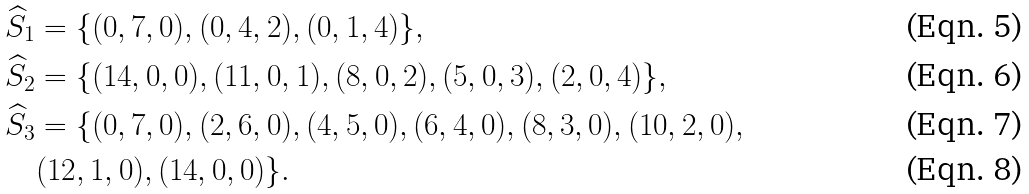<formula> <loc_0><loc_0><loc_500><loc_500>& \widehat { S } _ { 1 } = \{ ( 0 , 7 , 0 ) , ( 0 , 4 , 2 ) , ( 0 , 1 , 4 ) \} , \\ & \widehat { S } _ { 2 } = \{ ( 1 4 , 0 , 0 ) , ( 1 1 , 0 , 1 ) , ( 8 , 0 , 2 ) , ( 5 , 0 , 3 ) , ( 2 , 0 , 4 ) \} , \\ & \widehat { S } _ { 3 } = \{ ( 0 , 7 , 0 ) , ( 2 , 6 , 0 ) , ( 4 , 5 , 0 ) , ( 6 , 4 , 0 ) , ( 8 , 3 , 0 ) , ( 1 0 , 2 , 0 ) , \\ & \quad ( 1 2 , 1 , 0 ) , ( 1 4 , 0 , 0 ) \} .</formula> 